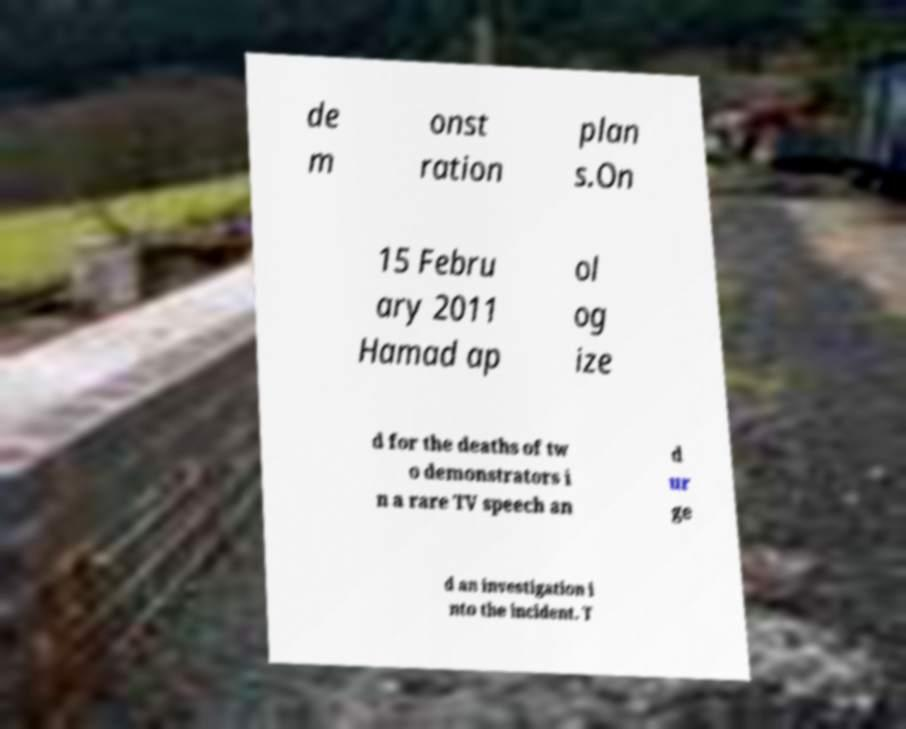Please read and relay the text visible in this image. What does it say? de m onst ration plan s.On 15 Febru ary 2011 Hamad ap ol og ize d for the deaths of tw o demonstrators i n a rare TV speech an d ur ge d an investigation i nto the incident. T 